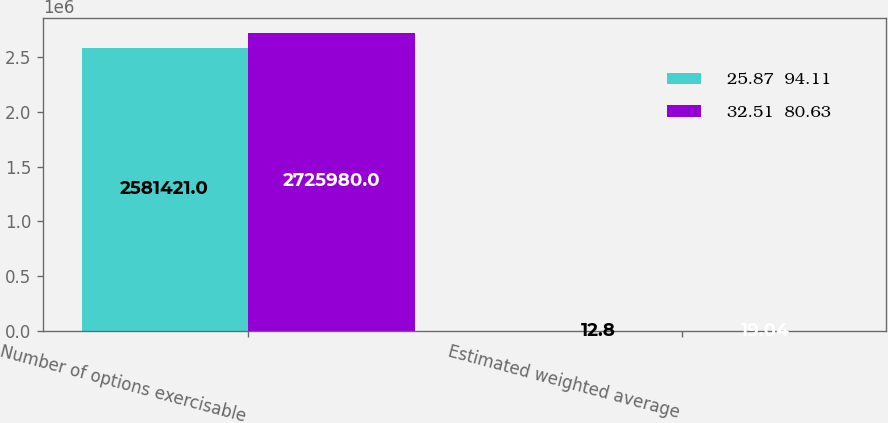Convert chart. <chart><loc_0><loc_0><loc_500><loc_500><stacked_bar_chart><ecel><fcel>Number of options exercisable<fcel>Estimated weighted average<nl><fcel>25.87  94.11<fcel>2.58142e+06<fcel>12.8<nl><fcel>32.51  80.63<fcel>2.72598e+06<fcel>19.04<nl></chart> 